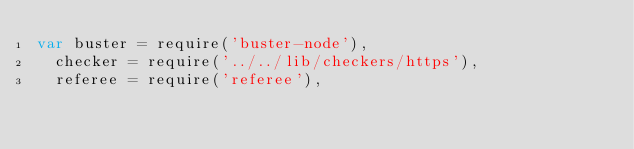Convert code to text. <code><loc_0><loc_0><loc_500><loc_500><_JavaScript_>var buster = require('buster-node'),
  checker = require('../../lib/checkers/https'),
  referee = require('referee'),</code> 